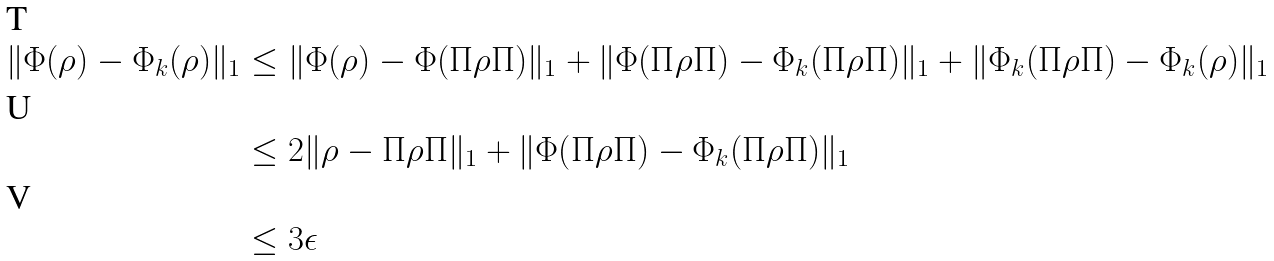<formula> <loc_0><loc_0><loc_500><loc_500>\| \Phi ( \rho ) - \Phi _ { k } ( \rho ) \| _ { 1 } & \leq \| \Phi ( \rho ) - \Phi ( \Pi \rho \Pi ) \| _ { 1 } + \| \Phi ( \Pi \rho \Pi ) - \Phi _ { k } ( \Pi \rho \Pi ) \| _ { 1 } + \| \Phi _ { k } ( \Pi \rho \Pi ) - \Phi _ { k } ( \rho ) \| _ { 1 } \\ & \leq 2 \| \rho - \Pi \rho \Pi \| _ { 1 } + \| \Phi ( \Pi \rho \Pi ) - \Phi _ { k } ( \Pi \rho \Pi ) \| _ { 1 } \\ & \leq 3 \epsilon</formula> 